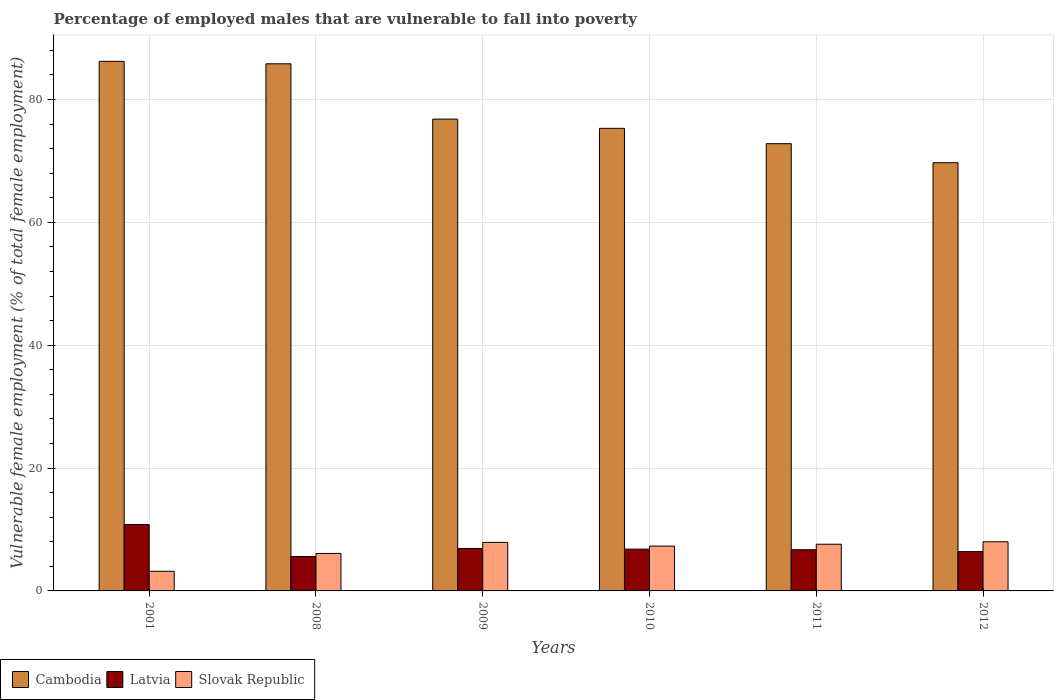How many different coloured bars are there?
Provide a short and direct response. 3. How many groups of bars are there?
Your response must be concise. 6. How many bars are there on the 5th tick from the right?
Your answer should be very brief. 3. What is the label of the 2nd group of bars from the left?
Keep it short and to the point. 2008. In how many cases, is the number of bars for a given year not equal to the number of legend labels?
Your answer should be very brief. 0. What is the percentage of employed males who are vulnerable to fall into poverty in Slovak Republic in 2012?
Your response must be concise. 8. Across all years, what is the maximum percentage of employed males who are vulnerable to fall into poverty in Latvia?
Provide a short and direct response. 10.8. Across all years, what is the minimum percentage of employed males who are vulnerable to fall into poverty in Cambodia?
Give a very brief answer. 69.7. In which year was the percentage of employed males who are vulnerable to fall into poverty in Cambodia minimum?
Offer a terse response. 2012. What is the total percentage of employed males who are vulnerable to fall into poverty in Cambodia in the graph?
Offer a terse response. 466.6. What is the difference between the percentage of employed males who are vulnerable to fall into poverty in Slovak Republic in 2010 and that in 2011?
Your response must be concise. -0.3. What is the difference between the percentage of employed males who are vulnerable to fall into poverty in Latvia in 2008 and the percentage of employed males who are vulnerable to fall into poverty in Slovak Republic in 2010?
Give a very brief answer. -1.7. What is the average percentage of employed males who are vulnerable to fall into poverty in Cambodia per year?
Provide a short and direct response. 77.77. In the year 2008, what is the difference between the percentage of employed males who are vulnerable to fall into poverty in Latvia and percentage of employed males who are vulnerable to fall into poverty in Slovak Republic?
Offer a terse response. -0.5. What is the ratio of the percentage of employed males who are vulnerable to fall into poverty in Latvia in 2001 to that in 2009?
Your answer should be compact. 1.57. Is the percentage of employed males who are vulnerable to fall into poverty in Slovak Republic in 2009 less than that in 2012?
Provide a short and direct response. Yes. What is the difference between the highest and the second highest percentage of employed males who are vulnerable to fall into poverty in Latvia?
Your answer should be compact. 3.9. What is the difference between the highest and the lowest percentage of employed males who are vulnerable to fall into poverty in Slovak Republic?
Give a very brief answer. 4.8. Is the sum of the percentage of employed males who are vulnerable to fall into poverty in Latvia in 2008 and 2011 greater than the maximum percentage of employed males who are vulnerable to fall into poverty in Slovak Republic across all years?
Your response must be concise. Yes. What does the 2nd bar from the left in 2009 represents?
Ensure brevity in your answer.  Latvia. What does the 1st bar from the right in 2010 represents?
Ensure brevity in your answer.  Slovak Republic. Is it the case that in every year, the sum of the percentage of employed males who are vulnerable to fall into poverty in Slovak Republic and percentage of employed males who are vulnerable to fall into poverty in Cambodia is greater than the percentage of employed males who are vulnerable to fall into poverty in Latvia?
Offer a very short reply. Yes. Are the values on the major ticks of Y-axis written in scientific E-notation?
Your response must be concise. No. Does the graph contain any zero values?
Offer a very short reply. No. Does the graph contain grids?
Offer a very short reply. Yes. How many legend labels are there?
Offer a terse response. 3. What is the title of the graph?
Make the answer very short. Percentage of employed males that are vulnerable to fall into poverty. Does "South Asia" appear as one of the legend labels in the graph?
Give a very brief answer. No. What is the label or title of the Y-axis?
Your response must be concise. Vulnerable female employment (% of total female employment). What is the Vulnerable female employment (% of total female employment) in Cambodia in 2001?
Provide a succinct answer. 86.2. What is the Vulnerable female employment (% of total female employment) of Latvia in 2001?
Your response must be concise. 10.8. What is the Vulnerable female employment (% of total female employment) in Slovak Republic in 2001?
Offer a terse response. 3.2. What is the Vulnerable female employment (% of total female employment) of Cambodia in 2008?
Give a very brief answer. 85.8. What is the Vulnerable female employment (% of total female employment) of Latvia in 2008?
Provide a short and direct response. 5.6. What is the Vulnerable female employment (% of total female employment) in Slovak Republic in 2008?
Offer a very short reply. 6.1. What is the Vulnerable female employment (% of total female employment) of Cambodia in 2009?
Ensure brevity in your answer.  76.8. What is the Vulnerable female employment (% of total female employment) of Latvia in 2009?
Your answer should be compact. 6.9. What is the Vulnerable female employment (% of total female employment) of Slovak Republic in 2009?
Your answer should be very brief. 7.9. What is the Vulnerable female employment (% of total female employment) in Cambodia in 2010?
Offer a terse response. 75.3. What is the Vulnerable female employment (% of total female employment) in Latvia in 2010?
Your answer should be compact. 6.8. What is the Vulnerable female employment (% of total female employment) in Slovak Republic in 2010?
Your answer should be compact. 7.3. What is the Vulnerable female employment (% of total female employment) of Cambodia in 2011?
Provide a short and direct response. 72.8. What is the Vulnerable female employment (% of total female employment) in Latvia in 2011?
Offer a very short reply. 6.7. What is the Vulnerable female employment (% of total female employment) of Slovak Republic in 2011?
Give a very brief answer. 7.6. What is the Vulnerable female employment (% of total female employment) in Cambodia in 2012?
Offer a terse response. 69.7. What is the Vulnerable female employment (% of total female employment) in Latvia in 2012?
Keep it short and to the point. 6.4. Across all years, what is the maximum Vulnerable female employment (% of total female employment) of Cambodia?
Offer a very short reply. 86.2. Across all years, what is the maximum Vulnerable female employment (% of total female employment) of Latvia?
Ensure brevity in your answer.  10.8. Across all years, what is the minimum Vulnerable female employment (% of total female employment) of Cambodia?
Give a very brief answer. 69.7. Across all years, what is the minimum Vulnerable female employment (% of total female employment) in Latvia?
Give a very brief answer. 5.6. Across all years, what is the minimum Vulnerable female employment (% of total female employment) in Slovak Republic?
Make the answer very short. 3.2. What is the total Vulnerable female employment (% of total female employment) of Cambodia in the graph?
Give a very brief answer. 466.6. What is the total Vulnerable female employment (% of total female employment) of Latvia in the graph?
Give a very brief answer. 43.2. What is the total Vulnerable female employment (% of total female employment) of Slovak Republic in the graph?
Provide a short and direct response. 40.1. What is the difference between the Vulnerable female employment (% of total female employment) in Latvia in 2001 and that in 2008?
Ensure brevity in your answer.  5.2. What is the difference between the Vulnerable female employment (% of total female employment) in Slovak Republic in 2001 and that in 2008?
Make the answer very short. -2.9. What is the difference between the Vulnerable female employment (% of total female employment) of Latvia in 2001 and that in 2010?
Give a very brief answer. 4. What is the difference between the Vulnerable female employment (% of total female employment) of Slovak Republic in 2001 and that in 2010?
Provide a short and direct response. -4.1. What is the difference between the Vulnerable female employment (% of total female employment) in Cambodia in 2001 and that in 2011?
Make the answer very short. 13.4. What is the difference between the Vulnerable female employment (% of total female employment) of Latvia in 2001 and that in 2011?
Keep it short and to the point. 4.1. What is the difference between the Vulnerable female employment (% of total female employment) of Latvia in 2001 and that in 2012?
Offer a very short reply. 4.4. What is the difference between the Vulnerable female employment (% of total female employment) in Cambodia in 2008 and that in 2009?
Offer a terse response. 9. What is the difference between the Vulnerable female employment (% of total female employment) of Cambodia in 2008 and that in 2010?
Ensure brevity in your answer.  10.5. What is the difference between the Vulnerable female employment (% of total female employment) of Cambodia in 2008 and that in 2011?
Your response must be concise. 13. What is the difference between the Vulnerable female employment (% of total female employment) of Cambodia in 2008 and that in 2012?
Your answer should be compact. 16.1. What is the difference between the Vulnerable female employment (% of total female employment) in Slovak Republic in 2008 and that in 2012?
Give a very brief answer. -1.9. What is the difference between the Vulnerable female employment (% of total female employment) of Slovak Republic in 2009 and that in 2011?
Offer a terse response. 0.3. What is the difference between the Vulnerable female employment (% of total female employment) in Cambodia in 2009 and that in 2012?
Keep it short and to the point. 7.1. What is the difference between the Vulnerable female employment (% of total female employment) of Slovak Republic in 2009 and that in 2012?
Ensure brevity in your answer.  -0.1. What is the difference between the Vulnerable female employment (% of total female employment) of Cambodia in 2010 and that in 2011?
Provide a short and direct response. 2.5. What is the difference between the Vulnerable female employment (% of total female employment) of Latvia in 2011 and that in 2012?
Keep it short and to the point. 0.3. What is the difference between the Vulnerable female employment (% of total female employment) of Cambodia in 2001 and the Vulnerable female employment (% of total female employment) of Latvia in 2008?
Your response must be concise. 80.6. What is the difference between the Vulnerable female employment (% of total female employment) of Cambodia in 2001 and the Vulnerable female employment (% of total female employment) of Slovak Republic in 2008?
Your response must be concise. 80.1. What is the difference between the Vulnerable female employment (% of total female employment) in Latvia in 2001 and the Vulnerable female employment (% of total female employment) in Slovak Republic in 2008?
Offer a terse response. 4.7. What is the difference between the Vulnerable female employment (% of total female employment) in Cambodia in 2001 and the Vulnerable female employment (% of total female employment) in Latvia in 2009?
Ensure brevity in your answer.  79.3. What is the difference between the Vulnerable female employment (% of total female employment) in Cambodia in 2001 and the Vulnerable female employment (% of total female employment) in Slovak Republic in 2009?
Provide a short and direct response. 78.3. What is the difference between the Vulnerable female employment (% of total female employment) of Cambodia in 2001 and the Vulnerable female employment (% of total female employment) of Latvia in 2010?
Provide a short and direct response. 79.4. What is the difference between the Vulnerable female employment (% of total female employment) in Cambodia in 2001 and the Vulnerable female employment (% of total female employment) in Slovak Republic in 2010?
Offer a very short reply. 78.9. What is the difference between the Vulnerable female employment (% of total female employment) of Cambodia in 2001 and the Vulnerable female employment (% of total female employment) of Latvia in 2011?
Offer a very short reply. 79.5. What is the difference between the Vulnerable female employment (% of total female employment) of Cambodia in 2001 and the Vulnerable female employment (% of total female employment) of Slovak Republic in 2011?
Your answer should be compact. 78.6. What is the difference between the Vulnerable female employment (% of total female employment) in Latvia in 2001 and the Vulnerable female employment (% of total female employment) in Slovak Republic in 2011?
Offer a very short reply. 3.2. What is the difference between the Vulnerable female employment (% of total female employment) in Cambodia in 2001 and the Vulnerable female employment (% of total female employment) in Latvia in 2012?
Make the answer very short. 79.8. What is the difference between the Vulnerable female employment (% of total female employment) of Cambodia in 2001 and the Vulnerable female employment (% of total female employment) of Slovak Republic in 2012?
Your answer should be compact. 78.2. What is the difference between the Vulnerable female employment (% of total female employment) of Latvia in 2001 and the Vulnerable female employment (% of total female employment) of Slovak Republic in 2012?
Offer a terse response. 2.8. What is the difference between the Vulnerable female employment (% of total female employment) in Cambodia in 2008 and the Vulnerable female employment (% of total female employment) in Latvia in 2009?
Make the answer very short. 78.9. What is the difference between the Vulnerable female employment (% of total female employment) of Cambodia in 2008 and the Vulnerable female employment (% of total female employment) of Slovak Republic in 2009?
Ensure brevity in your answer.  77.9. What is the difference between the Vulnerable female employment (% of total female employment) in Cambodia in 2008 and the Vulnerable female employment (% of total female employment) in Latvia in 2010?
Give a very brief answer. 79. What is the difference between the Vulnerable female employment (% of total female employment) in Cambodia in 2008 and the Vulnerable female employment (% of total female employment) in Slovak Republic in 2010?
Offer a terse response. 78.5. What is the difference between the Vulnerable female employment (% of total female employment) of Cambodia in 2008 and the Vulnerable female employment (% of total female employment) of Latvia in 2011?
Your answer should be compact. 79.1. What is the difference between the Vulnerable female employment (% of total female employment) in Cambodia in 2008 and the Vulnerable female employment (% of total female employment) in Slovak Republic in 2011?
Your answer should be compact. 78.2. What is the difference between the Vulnerable female employment (% of total female employment) in Latvia in 2008 and the Vulnerable female employment (% of total female employment) in Slovak Republic in 2011?
Make the answer very short. -2. What is the difference between the Vulnerable female employment (% of total female employment) in Cambodia in 2008 and the Vulnerable female employment (% of total female employment) in Latvia in 2012?
Give a very brief answer. 79.4. What is the difference between the Vulnerable female employment (% of total female employment) of Cambodia in 2008 and the Vulnerable female employment (% of total female employment) of Slovak Republic in 2012?
Provide a succinct answer. 77.8. What is the difference between the Vulnerable female employment (% of total female employment) of Cambodia in 2009 and the Vulnerable female employment (% of total female employment) of Slovak Republic in 2010?
Your answer should be very brief. 69.5. What is the difference between the Vulnerable female employment (% of total female employment) of Cambodia in 2009 and the Vulnerable female employment (% of total female employment) of Latvia in 2011?
Your response must be concise. 70.1. What is the difference between the Vulnerable female employment (% of total female employment) in Cambodia in 2009 and the Vulnerable female employment (% of total female employment) in Slovak Republic in 2011?
Your answer should be compact. 69.2. What is the difference between the Vulnerable female employment (% of total female employment) of Cambodia in 2009 and the Vulnerable female employment (% of total female employment) of Latvia in 2012?
Keep it short and to the point. 70.4. What is the difference between the Vulnerable female employment (% of total female employment) in Cambodia in 2009 and the Vulnerable female employment (% of total female employment) in Slovak Republic in 2012?
Make the answer very short. 68.8. What is the difference between the Vulnerable female employment (% of total female employment) in Cambodia in 2010 and the Vulnerable female employment (% of total female employment) in Latvia in 2011?
Make the answer very short. 68.6. What is the difference between the Vulnerable female employment (% of total female employment) in Cambodia in 2010 and the Vulnerable female employment (% of total female employment) in Slovak Republic in 2011?
Make the answer very short. 67.7. What is the difference between the Vulnerable female employment (% of total female employment) of Cambodia in 2010 and the Vulnerable female employment (% of total female employment) of Latvia in 2012?
Your response must be concise. 68.9. What is the difference between the Vulnerable female employment (% of total female employment) in Cambodia in 2010 and the Vulnerable female employment (% of total female employment) in Slovak Republic in 2012?
Make the answer very short. 67.3. What is the difference between the Vulnerable female employment (% of total female employment) of Cambodia in 2011 and the Vulnerable female employment (% of total female employment) of Latvia in 2012?
Your answer should be very brief. 66.4. What is the difference between the Vulnerable female employment (% of total female employment) in Cambodia in 2011 and the Vulnerable female employment (% of total female employment) in Slovak Republic in 2012?
Provide a succinct answer. 64.8. What is the average Vulnerable female employment (% of total female employment) in Cambodia per year?
Your answer should be very brief. 77.77. What is the average Vulnerable female employment (% of total female employment) of Latvia per year?
Make the answer very short. 7.2. What is the average Vulnerable female employment (% of total female employment) of Slovak Republic per year?
Your response must be concise. 6.68. In the year 2001, what is the difference between the Vulnerable female employment (% of total female employment) of Cambodia and Vulnerable female employment (% of total female employment) of Latvia?
Your answer should be compact. 75.4. In the year 2008, what is the difference between the Vulnerable female employment (% of total female employment) in Cambodia and Vulnerable female employment (% of total female employment) in Latvia?
Ensure brevity in your answer.  80.2. In the year 2008, what is the difference between the Vulnerable female employment (% of total female employment) in Cambodia and Vulnerable female employment (% of total female employment) in Slovak Republic?
Keep it short and to the point. 79.7. In the year 2008, what is the difference between the Vulnerable female employment (% of total female employment) in Latvia and Vulnerable female employment (% of total female employment) in Slovak Republic?
Your answer should be very brief. -0.5. In the year 2009, what is the difference between the Vulnerable female employment (% of total female employment) in Cambodia and Vulnerable female employment (% of total female employment) in Latvia?
Offer a very short reply. 69.9. In the year 2009, what is the difference between the Vulnerable female employment (% of total female employment) in Cambodia and Vulnerable female employment (% of total female employment) in Slovak Republic?
Give a very brief answer. 68.9. In the year 2010, what is the difference between the Vulnerable female employment (% of total female employment) in Cambodia and Vulnerable female employment (% of total female employment) in Latvia?
Offer a very short reply. 68.5. In the year 2010, what is the difference between the Vulnerable female employment (% of total female employment) of Cambodia and Vulnerable female employment (% of total female employment) of Slovak Republic?
Offer a very short reply. 68. In the year 2010, what is the difference between the Vulnerable female employment (% of total female employment) in Latvia and Vulnerable female employment (% of total female employment) in Slovak Republic?
Provide a succinct answer. -0.5. In the year 2011, what is the difference between the Vulnerable female employment (% of total female employment) in Cambodia and Vulnerable female employment (% of total female employment) in Latvia?
Keep it short and to the point. 66.1. In the year 2011, what is the difference between the Vulnerable female employment (% of total female employment) in Cambodia and Vulnerable female employment (% of total female employment) in Slovak Republic?
Your answer should be very brief. 65.2. In the year 2012, what is the difference between the Vulnerable female employment (% of total female employment) in Cambodia and Vulnerable female employment (% of total female employment) in Latvia?
Provide a short and direct response. 63.3. In the year 2012, what is the difference between the Vulnerable female employment (% of total female employment) of Cambodia and Vulnerable female employment (% of total female employment) of Slovak Republic?
Your response must be concise. 61.7. In the year 2012, what is the difference between the Vulnerable female employment (% of total female employment) of Latvia and Vulnerable female employment (% of total female employment) of Slovak Republic?
Ensure brevity in your answer.  -1.6. What is the ratio of the Vulnerable female employment (% of total female employment) in Latvia in 2001 to that in 2008?
Provide a succinct answer. 1.93. What is the ratio of the Vulnerable female employment (% of total female employment) in Slovak Republic in 2001 to that in 2008?
Make the answer very short. 0.52. What is the ratio of the Vulnerable female employment (% of total female employment) in Cambodia in 2001 to that in 2009?
Your answer should be compact. 1.12. What is the ratio of the Vulnerable female employment (% of total female employment) of Latvia in 2001 to that in 2009?
Provide a short and direct response. 1.57. What is the ratio of the Vulnerable female employment (% of total female employment) in Slovak Republic in 2001 to that in 2009?
Provide a succinct answer. 0.41. What is the ratio of the Vulnerable female employment (% of total female employment) in Cambodia in 2001 to that in 2010?
Your answer should be compact. 1.14. What is the ratio of the Vulnerable female employment (% of total female employment) of Latvia in 2001 to that in 2010?
Offer a very short reply. 1.59. What is the ratio of the Vulnerable female employment (% of total female employment) in Slovak Republic in 2001 to that in 2010?
Give a very brief answer. 0.44. What is the ratio of the Vulnerable female employment (% of total female employment) in Cambodia in 2001 to that in 2011?
Your answer should be very brief. 1.18. What is the ratio of the Vulnerable female employment (% of total female employment) of Latvia in 2001 to that in 2011?
Your response must be concise. 1.61. What is the ratio of the Vulnerable female employment (% of total female employment) in Slovak Republic in 2001 to that in 2011?
Provide a short and direct response. 0.42. What is the ratio of the Vulnerable female employment (% of total female employment) in Cambodia in 2001 to that in 2012?
Your response must be concise. 1.24. What is the ratio of the Vulnerable female employment (% of total female employment) of Latvia in 2001 to that in 2012?
Make the answer very short. 1.69. What is the ratio of the Vulnerable female employment (% of total female employment) in Cambodia in 2008 to that in 2009?
Keep it short and to the point. 1.12. What is the ratio of the Vulnerable female employment (% of total female employment) in Latvia in 2008 to that in 2009?
Your answer should be compact. 0.81. What is the ratio of the Vulnerable female employment (% of total female employment) in Slovak Republic in 2008 to that in 2009?
Your answer should be compact. 0.77. What is the ratio of the Vulnerable female employment (% of total female employment) of Cambodia in 2008 to that in 2010?
Give a very brief answer. 1.14. What is the ratio of the Vulnerable female employment (% of total female employment) in Latvia in 2008 to that in 2010?
Provide a short and direct response. 0.82. What is the ratio of the Vulnerable female employment (% of total female employment) of Slovak Republic in 2008 to that in 2010?
Provide a short and direct response. 0.84. What is the ratio of the Vulnerable female employment (% of total female employment) in Cambodia in 2008 to that in 2011?
Provide a succinct answer. 1.18. What is the ratio of the Vulnerable female employment (% of total female employment) of Latvia in 2008 to that in 2011?
Offer a terse response. 0.84. What is the ratio of the Vulnerable female employment (% of total female employment) of Slovak Republic in 2008 to that in 2011?
Your answer should be very brief. 0.8. What is the ratio of the Vulnerable female employment (% of total female employment) in Cambodia in 2008 to that in 2012?
Provide a succinct answer. 1.23. What is the ratio of the Vulnerable female employment (% of total female employment) of Slovak Republic in 2008 to that in 2012?
Your answer should be very brief. 0.76. What is the ratio of the Vulnerable female employment (% of total female employment) of Cambodia in 2009 to that in 2010?
Your answer should be compact. 1.02. What is the ratio of the Vulnerable female employment (% of total female employment) in Latvia in 2009 to that in 2010?
Offer a terse response. 1.01. What is the ratio of the Vulnerable female employment (% of total female employment) of Slovak Republic in 2009 to that in 2010?
Offer a terse response. 1.08. What is the ratio of the Vulnerable female employment (% of total female employment) of Cambodia in 2009 to that in 2011?
Offer a very short reply. 1.05. What is the ratio of the Vulnerable female employment (% of total female employment) of Latvia in 2009 to that in 2011?
Give a very brief answer. 1.03. What is the ratio of the Vulnerable female employment (% of total female employment) of Slovak Republic in 2009 to that in 2011?
Ensure brevity in your answer.  1.04. What is the ratio of the Vulnerable female employment (% of total female employment) in Cambodia in 2009 to that in 2012?
Keep it short and to the point. 1.1. What is the ratio of the Vulnerable female employment (% of total female employment) in Latvia in 2009 to that in 2012?
Offer a terse response. 1.08. What is the ratio of the Vulnerable female employment (% of total female employment) in Slovak Republic in 2009 to that in 2012?
Your answer should be very brief. 0.99. What is the ratio of the Vulnerable female employment (% of total female employment) of Cambodia in 2010 to that in 2011?
Provide a short and direct response. 1.03. What is the ratio of the Vulnerable female employment (% of total female employment) in Latvia in 2010 to that in 2011?
Ensure brevity in your answer.  1.01. What is the ratio of the Vulnerable female employment (% of total female employment) in Slovak Republic in 2010 to that in 2011?
Ensure brevity in your answer.  0.96. What is the ratio of the Vulnerable female employment (% of total female employment) in Cambodia in 2010 to that in 2012?
Ensure brevity in your answer.  1.08. What is the ratio of the Vulnerable female employment (% of total female employment) in Latvia in 2010 to that in 2012?
Offer a terse response. 1.06. What is the ratio of the Vulnerable female employment (% of total female employment) in Slovak Republic in 2010 to that in 2012?
Your answer should be compact. 0.91. What is the ratio of the Vulnerable female employment (% of total female employment) of Cambodia in 2011 to that in 2012?
Make the answer very short. 1.04. What is the ratio of the Vulnerable female employment (% of total female employment) in Latvia in 2011 to that in 2012?
Keep it short and to the point. 1.05. What is the ratio of the Vulnerable female employment (% of total female employment) of Slovak Republic in 2011 to that in 2012?
Make the answer very short. 0.95. What is the difference between the highest and the second highest Vulnerable female employment (% of total female employment) of Cambodia?
Provide a short and direct response. 0.4. What is the difference between the highest and the second highest Vulnerable female employment (% of total female employment) of Slovak Republic?
Your response must be concise. 0.1. What is the difference between the highest and the lowest Vulnerable female employment (% of total female employment) in Cambodia?
Offer a very short reply. 16.5. What is the difference between the highest and the lowest Vulnerable female employment (% of total female employment) in Latvia?
Provide a succinct answer. 5.2. 